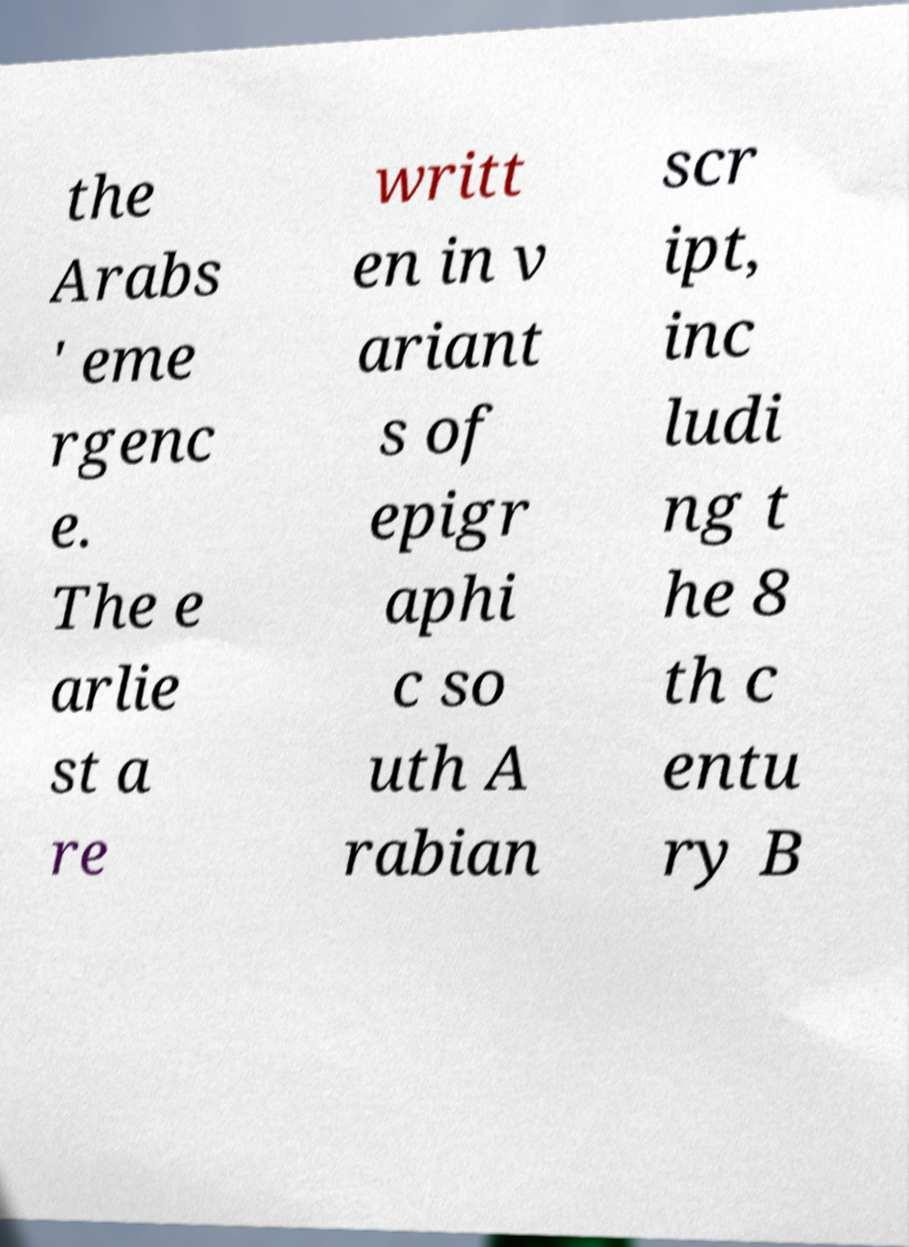Can you accurately transcribe the text from the provided image for me? the Arabs ' eme rgenc e. The e arlie st a re writt en in v ariant s of epigr aphi c so uth A rabian scr ipt, inc ludi ng t he 8 th c entu ry B 